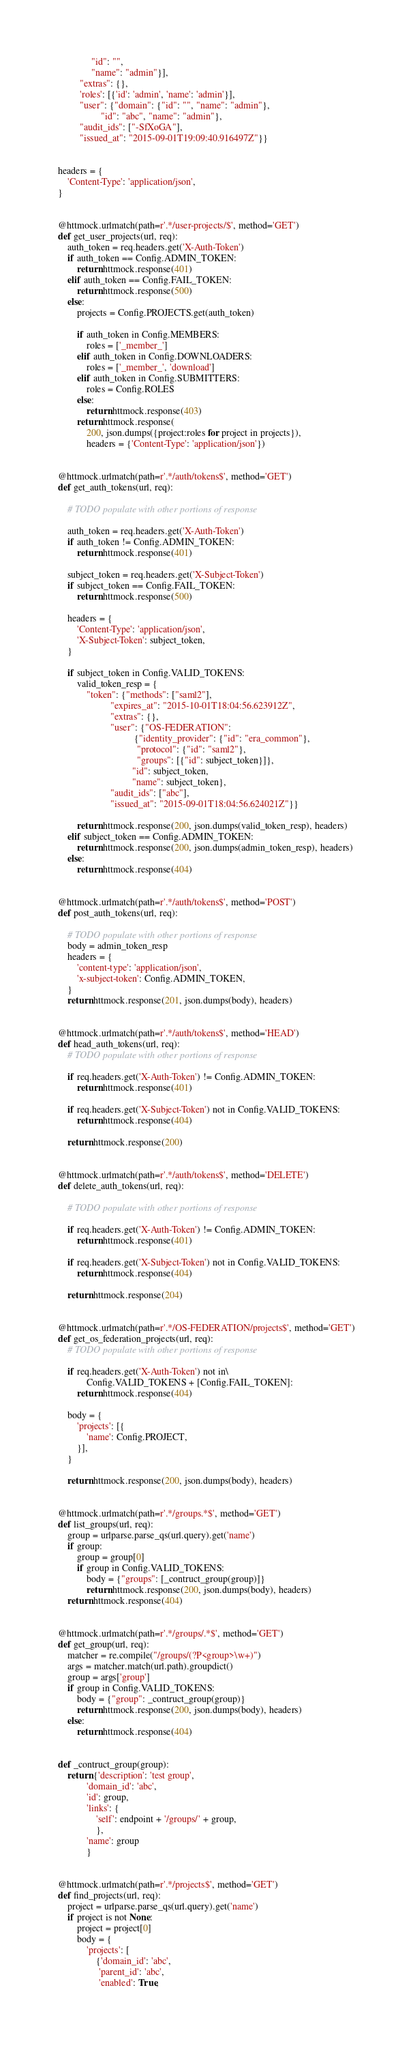<code> <loc_0><loc_0><loc_500><loc_500><_Python_>              "id": "",
              "name": "admin"}],
         "extras": {},
         'roles': [{'id': 'admin', 'name': 'admin'}],
         "user": {"domain": {"id": "", "name": "admin"},
                  "id": "abc", "name": "admin"},
         "audit_ids": ["-SfXoGA"],
         "issued_at": "2015-09-01T19:09:40.916497Z"}}


headers = {
    'Content-Type': 'application/json',
}


@httmock.urlmatch(path=r'.*/user-projects/$', method='GET')
def get_user_projects(url, req):
    auth_token = req.headers.get('X-Auth-Token')
    if auth_token == Config.ADMIN_TOKEN:
        return httmock.response(401)
    elif auth_token == Config.FAIL_TOKEN:
        return httmock.response(500)
    else:
        projects = Config.PROJECTS.get(auth_token)

        if auth_token in Config.MEMBERS:
            roles = ['_member_']
        elif auth_token in Config.DOWNLOADERS:
            roles = ['_member_', 'download']
        elif auth_token in Config.SUBMITTERS:
            roles = Config.ROLES
        else:
            return httmock.response(403)
        return httmock.response(
            200, json.dumps({project:roles for project in projects}),
            headers = {'Content-Type': 'application/json'})


@httmock.urlmatch(path=r'.*/auth/tokens$', method='GET')
def get_auth_tokens(url, req):

    # TODO populate with other portions of response

    auth_token = req.headers.get('X-Auth-Token')
    if auth_token != Config.ADMIN_TOKEN:
        return httmock.response(401)

    subject_token = req.headers.get('X-Subject-Token')
    if subject_token == Config.FAIL_TOKEN:
        return httmock.response(500)

    headers = {
        'Content-Type': 'application/json',
        'X-Subject-Token': subject_token,
    }

    if subject_token in Config.VALID_TOKENS:
        valid_token_resp = {
            "token": {"methods": ["saml2"],
                      "expires_at": "2015-10-01T18:04:56.623912Z",
                      "extras": {},
                      "user": {"OS-FEDERATION":
                                {"identity_provider": {"id": "era_common"},
                                 "protocol": {"id": "saml2"},
                                 "groups": [{"id": subject_token}]},
                               "id": subject_token,
                               "name": subject_token},
                      "audit_ids": ["abc"],
                      "issued_at": "2015-09-01T18:04:56.624021Z"}}

        return httmock.response(200, json.dumps(valid_token_resp), headers)
    elif subject_token == Config.ADMIN_TOKEN:
        return httmock.response(200, json.dumps(admin_token_resp), headers)
    else:
        return httmock.response(404)


@httmock.urlmatch(path=r'.*/auth/tokens$', method='POST')
def post_auth_tokens(url, req):

    # TODO populate with other portions of response
    body = admin_token_resp
    headers = {
        'content-type': 'application/json',
        'x-subject-token': Config.ADMIN_TOKEN,
    }
    return httmock.response(201, json.dumps(body), headers)


@httmock.urlmatch(path=r'.*/auth/tokens$', method='HEAD')
def head_auth_tokens(url, req):
    # TODO populate with other portions of response

    if req.headers.get('X-Auth-Token') != Config.ADMIN_TOKEN:
        return httmock.response(401)

    if req.headers.get('X-Subject-Token') not in Config.VALID_TOKENS:
        return httmock.response(404)

    return httmock.response(200)


@httmock.urlmatch(path=r'.*/auth/tokens$', method='DELETE')
def delete_auth_tokens(url, req):

    # TODO populate with other portions of response

    if req.headers.get('X-Auth-Token') != Config.ADMIN_TOKEN:
        return httmock.response(401)

    if req.headers.get('X-Subject-Token') not in Config.VALID_TOKENS:
        return httmock.response(404)

    return httmock.response(204)


@httmock.urlmatch(path=r'.*/OS-FEDERATION/projects$', method='GET')
def get_os_federation_projects(url, req):
    # TODO populate with other portions of response

    if req.headers.get('X-Auth-Token') not in\
            Config.VALID_TOKENS + [Config.FAIL_TOKEN]:
        return httmock.response(404)

    body = {
        'projects': [{
            'name': Config.PROJECT,
        }],
    }

    return httmock.response(200, json.dumps(body), headers)


@httmock.urlmatch(path=r'.*/groups.*$', method='GET')
def list_groups(url, req):
    group = urlparse.parse_qs(url.query).get('name')
    if group:
        group = group[0]
        if group in Config.VALID_TOKENS:
            body = {"groups": [_contruct_group(group)]}
            return httmock.response(200, json.dumps(body), headers)
    return httmock.response(404)


@httmock.urlmatch(path=r'.*/groups/.*$', method='GET')
def get_group(url, req):
    matcher = re.compile("/groups/(?P<group>\w+)")
    args = matcher.match(url.path).groupdict()
    group = args['group']
    if group in Config.VALID_TOKENS:
        body = {"group": _contruct_group(group)}
        return httmock.response(200, json.dumps(body), headers)
    else:
        return httmock.response(404)


def _contruct_group(group):
    return {'description': 'test group',
            'domain_id': 'abc',
            'id': group,
            'links': {
                'self': endpoint + '/groups/' + group,
                },
            'name': group
            }


@httmock.urlmatch(path=r'.*/projects$', method='GET')
def find_projects(url, req):
    project = urlparse.parse_qs(url.query).get('name')
    if project is not None:
        project = project[0]
        body = {
            'projects': [
                {'domain_id': 'abc',
                 'parent_id': 'abc',
                 'enabled': True,</code> 